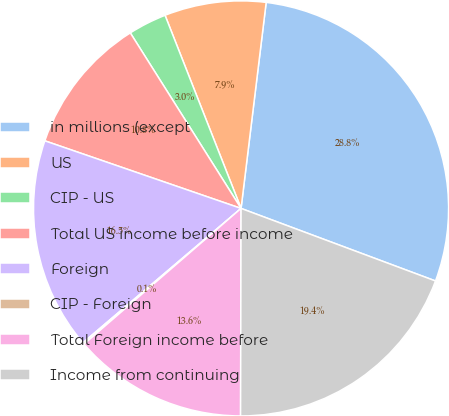Convert chart. <chart><loc_0><loc_0><loc_500><loc_500><pie_chart><fcel>in millions (except<fcel>US<fcel>CIP - US<fcel>Total US income before income<fcel>Foreign<fcel>CIP - Foreign<fcel>Total Foreign income before<fcel>Income from continuing<nl><fcel>28.75%<fcel>7.9%<fcel>2.99%<fcel>10.76%<fcel>16.49%<fcel>0.13%<fcel>13.62%<fcel>19.35%<nl></chart> 